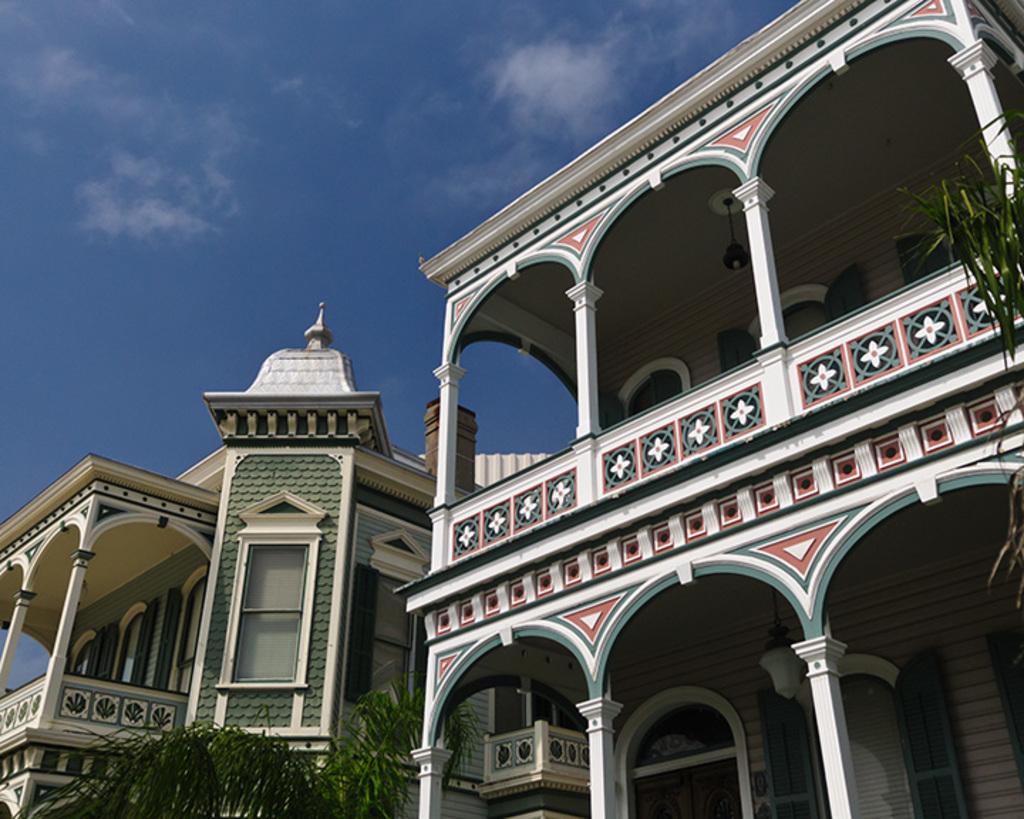In one or two sentences, can you explain what this image depicts? On the left side, there is a tree having green color leaves. On the right side, there is a tree and a building. In the background, there is a building which is having glass windows and there are clouds in the blue sky. 